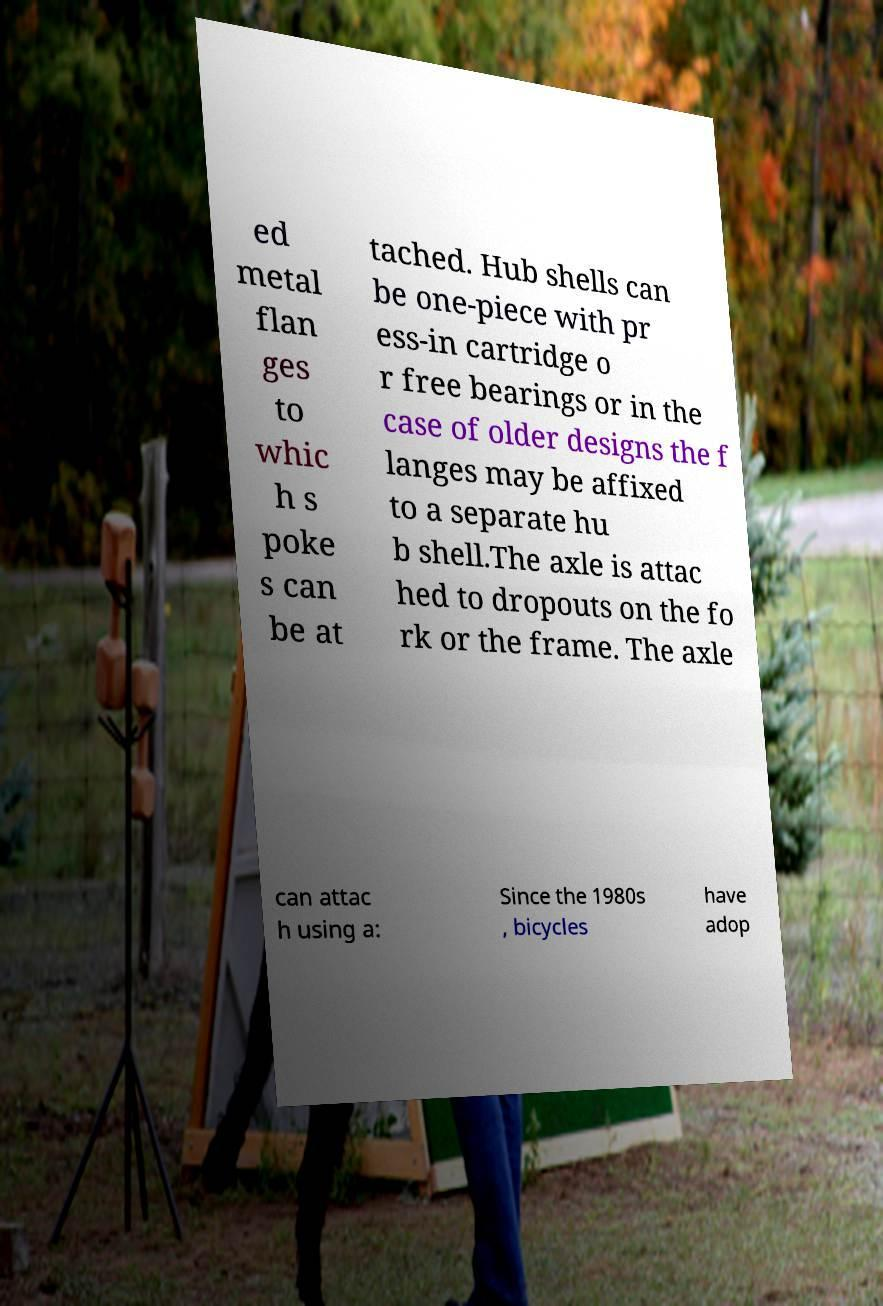I need the written content from this picture converted into text. Can you do that? ed metal flan ges to whic h s poke s can be at tached. Hub shells can be one-piece with pr ess-in cartridge o r free bearings or in the case of older designs the f langes may be affixed to a separate hu b shell.The axle is attac hed to dropouts on the fo rk or the frame. The axle can attac h using a: Since the 1980s , bicycles have adop 